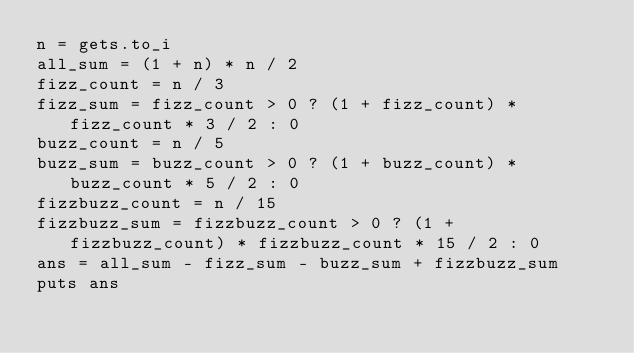Convert code to text. <code><loc_0><loc_0><loc_500><loc_500><_Ruby_>n = gets.to_i
all_sum = (1 + n) * n / 2
fizz_count = n / 3
fizz_sum = fizz_count > 0 ? (1 + fizz_count) * fizz_count * 3 / 2 : 0
buzz_count = n / 5
buzz_sum = buzz_count > 0 ? (1 + buzz_count) * buzz_count * 5 / 2 : 0
fizzbuzz_count = n / 15
fizzbuzz_sum = fizzbuzz_count > 0 ? (1 + fizzbuzz_count) * fizzbuzz_count * 15 / 2 : 0
ans = all_sum - fizz_sum - buzz_sum + fizzbuzz_sum
puts ans
</code> 